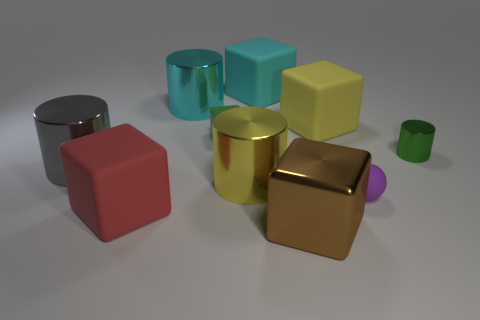Subtract all rubber blocks. How many blocks are left? 1 Subtract all yellow cylinders. How many cylinders are left? 3 Subtract all cylinders. How many objects are left? 6 Add 9 cyan matte things. How many cyan matte things exist? 10 Subtract 1 yellow cylinders. How many objects are left? 9 Subtract 3 cubes. How many cubes are left? 2 Subtract all blue cylinders. Subtract all yellow spheres. How many cylinders are left? 4 Subtract all large cylinders. Subtract all large green rubber spheres. How many objects are left? 7 Add 5 big yellow blocks. How many big yellow blocks are left? 6 